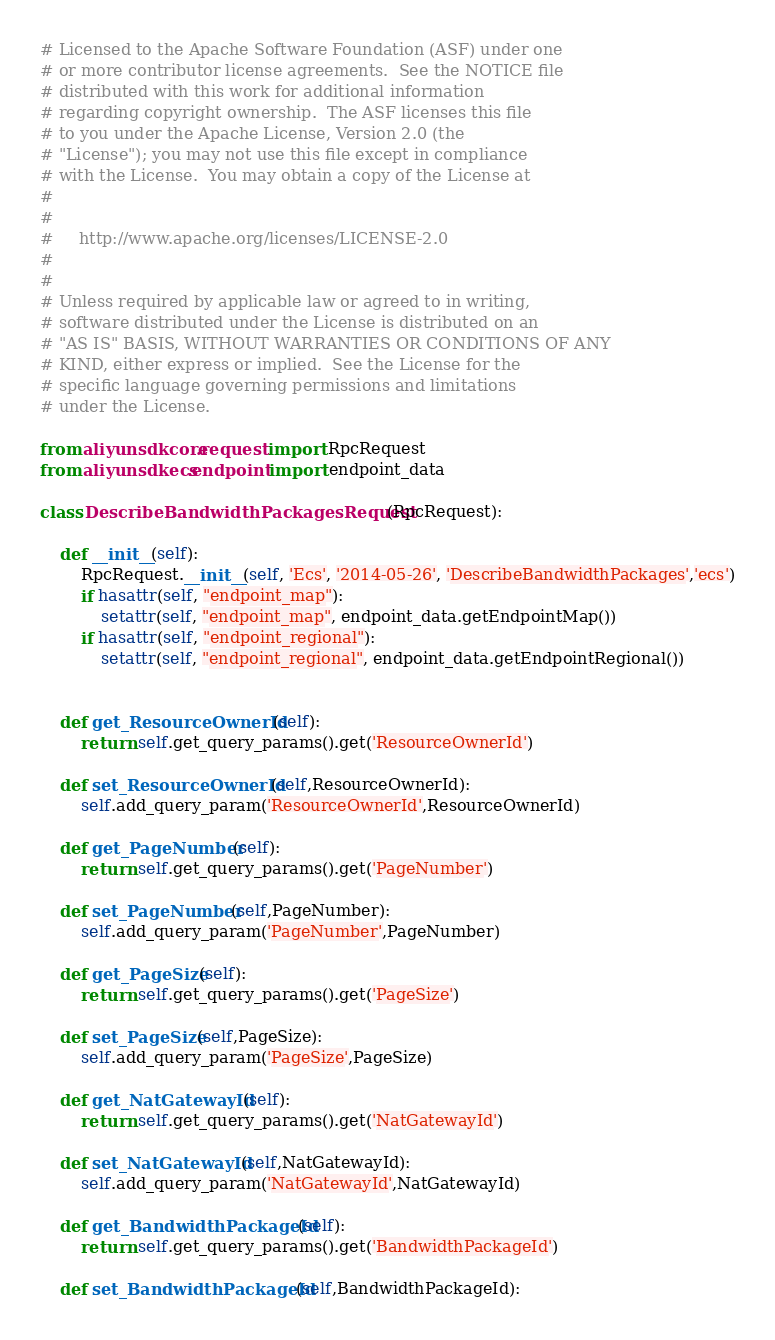Convert code to text. <code><loc_0><loc_0><loc_500><loc_500><_Python_># Licensed to the Apache Software Foundation (ASF) under one
# or more contributor license agreements.  See the NOTICE file
# distributed with this work for additional information
# regarding copyright ownership.  The ASF licenses this file
# to you under the Apache License, Version 2.0 (the
# "License"); you may not use this file except in compliance
# with the License.  You may obtain a copy of the License at
#
#
#     http://www.apache.org/licenses/LICENSE-2.0
#
#
# Unless required by applicable law or agreed to in writing,
# software distributed under the License is distributed on an
# "AS IS" BASIS, WITHOUT WARRANTIES OR CONDITIONS OF ANY
# KIND, either express or implied.  See the License for the
# specific language governing permissions and limitations
# under the License.

from aliyunsdkcore.request import RpcRequest
from aliyunsdkecs.endpoint import endpoint_data

class DescribeBandwidthPackagesRequest(RpcRequest):

	def __init__(self):
		RpcRequest.__init__(self, 'Ecs', '2014-05-26', 'DescribeBandwidthPackages','ecs')
		if hasattr(self, "endpoint_map"):
			setattr(self, "endpoint_map", endpoint_data.getEndpointMap())
		if hasattr(self, "endpoint_regional"):
			setattr(self, "endpoint_regional", endpoint_data.getEndpointRegional())


	def get_ResourceOwnerId(self):
		return self.get_query_params().get('ResourceOwnerId')

	def set_ResourceOwnerId(self,ResourceOwnerId):
		self.add_query_param('ResourceOwnerId',ResourceOwnerId)

	def get_PageNumber(self):
		return self.get_query_params().get('PageNumber')

	def set_PageNumber(self,PageNumber):
		self.add_query_param('PageNumber',PageNumber)

	def get_PageSize(self):
		return self.get_query_params().get('PageSize')

	def set_PageSize(self,PageSize):
		self.add_query_param('PageSize',PageSize)

	def get_NatGatewayId(self):
		return self.get_query_params().get('NatGatewayId')

	def set_NatGatewayId(self,NatGatewayId):
		self.add_query_param('NatGatewayId',NatGatewayId)

	def get_BandwidthPackageId(self):
		return self.get_query_params().get('BandwidthPackageId')

	def set_BandwidthPackageId(self,BandwidthPackageId):</code> 